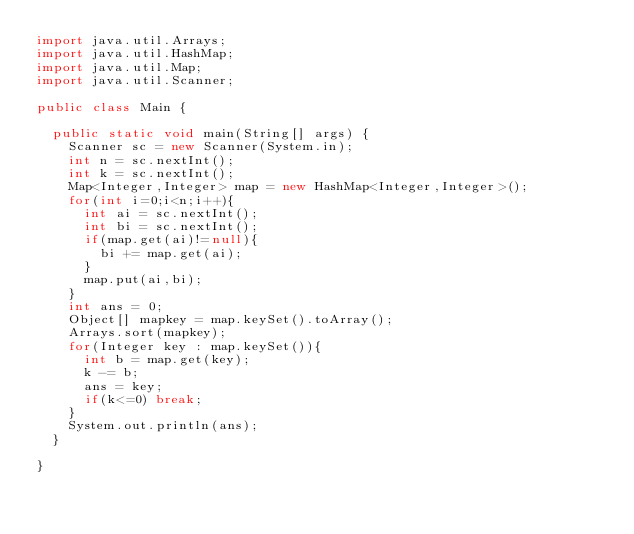<code> <loc_0><loc_0><loc_500><loc_500><_Java_>import java.util.Arrays;
import java.util.HashMap;
import java.util.Map;
import java.util.Scanner;

public class Main {

	public static void main(String[] args) {
		Scanner sc = new Scanner(System.in);
		int n = sc.nextInt();
		int k = sc.nextInt();
		Map<Integer,Integer> map = new HashMap<Integer,Integer>();
		for(int i=0;i<n;i++){
			int ai = sc.nextInt();
			int bi = sc.nextInt();
			if(map.get(ai)!=null){
				bi += map.get(ai);
			}
			map.put(ai,bi);
		}
		int ans = 0;
		Object[] mapkey = map.keySet().toArray();
		Arrays.sort(mapkey);
		for(Integer key : map.keySet()){
			int b = map.get(key);
			k -= b;
			ans = key;
			if(k<=0) break;
		}
		System.out.println(ans);
	}

}</code> 